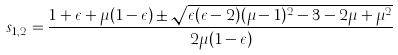Convert formula to latex. <formula><loc_0><loc_0><loc_500><loc_500>s _ { 1 , 2 } = \frac { 1 + \epsilon + \mu ( 1 - \epsilon ) \pm \sqrt { \epsilon ( \epsilon - 2 ) ( \mu - 1 ) ^ { 2 } - 3 - 2 \mu + \mu ^ { 2 } } } { 2 \mu ( 1 - \epsilon ) }</formula> 